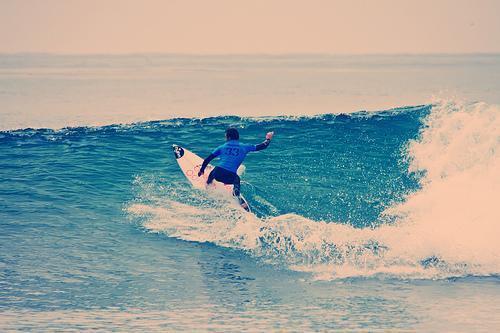How many people are in the picture?
Give a very brief answer. 1. 